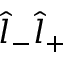Convert formula to latex. <formula><loc_0><loc_0><loc_500><loc_500>\hat { l } _ { - } \hat { l } _ { + }</formula> 